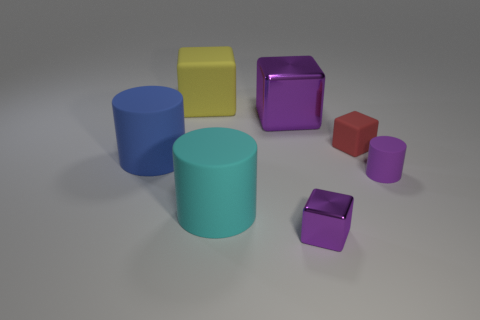What number of spheres are either blue matte things or big metallic things?
Ensure brevity in your answer.  0. What number of big blue things are on the right side of the metal block that is on the left side of the tiny cube that is in front of the blue rubber cylinder?
Give a very brief answer. 0. What size is the other metal cube that is the same color as the tiny metallic block?
Ensure brevity in your answer.  Large. Are there any tiny balls made of the same material as the yellow object?
Keep it short and to the point. No. Are the cyan cylinder and the red object made of the same material?
Ensure brevity in your answer.  Yes. How many large cylinders are in front of the small rubber object that is in front of the big blue cylinder?
Your answer should be very brief. 1. How many purple things are either small cylinders or rubber objects?
Offer a very short reply. 1. What shape is the metal thing in front of the rubber cylinder that is on the right side of the metal thing that is behind the red thing?
Keep it short and to the point. Cube. What is the color of the other metallic object that is the same size as the yellow thing?
Your answer should be compact. Purple. How many other large shiny things are the same shape as the yellow thing?
Give a very brief answer. 1. 